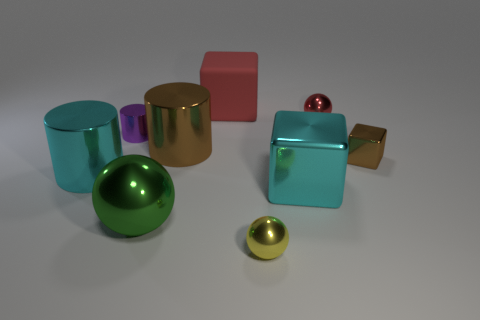Is there anything else that has the same material as the large red cube?
Your answer should be very brief. No. There is another large object that is the same shape as the red matte thing; what is its material?
Ensure brevity in your answer.  Metal. Are there more big cyan shiny cylinders than small matte blocks?
Your answer should be very brief. Yes. Do the rubber thing and the small shiny sphere that is behind the cyan cube have the same color?
Keep it short and to the point. Yes. There is a cylinder that is both behind the tiny brown object and in front of the tiny cylinder; what is its color?
Provide a succinct answer. Brown. How many other things are there of the same material as the big ball?
Your answer should be very brief. 7. Is the number of red matte cubes less than the number of big gray cylinders?
Offer a very short reply. No. Is the material of the small red thing the same as the tiny sphere that is in front of the large sphere?
Your answer should be very brief. Yes. There is a brown thing right of the red shiny thing; what shape is it?
Offer a very short reply. Cube. Are there any other things of the same color as the big metal sphere?
Your answer should be very brief. No. 